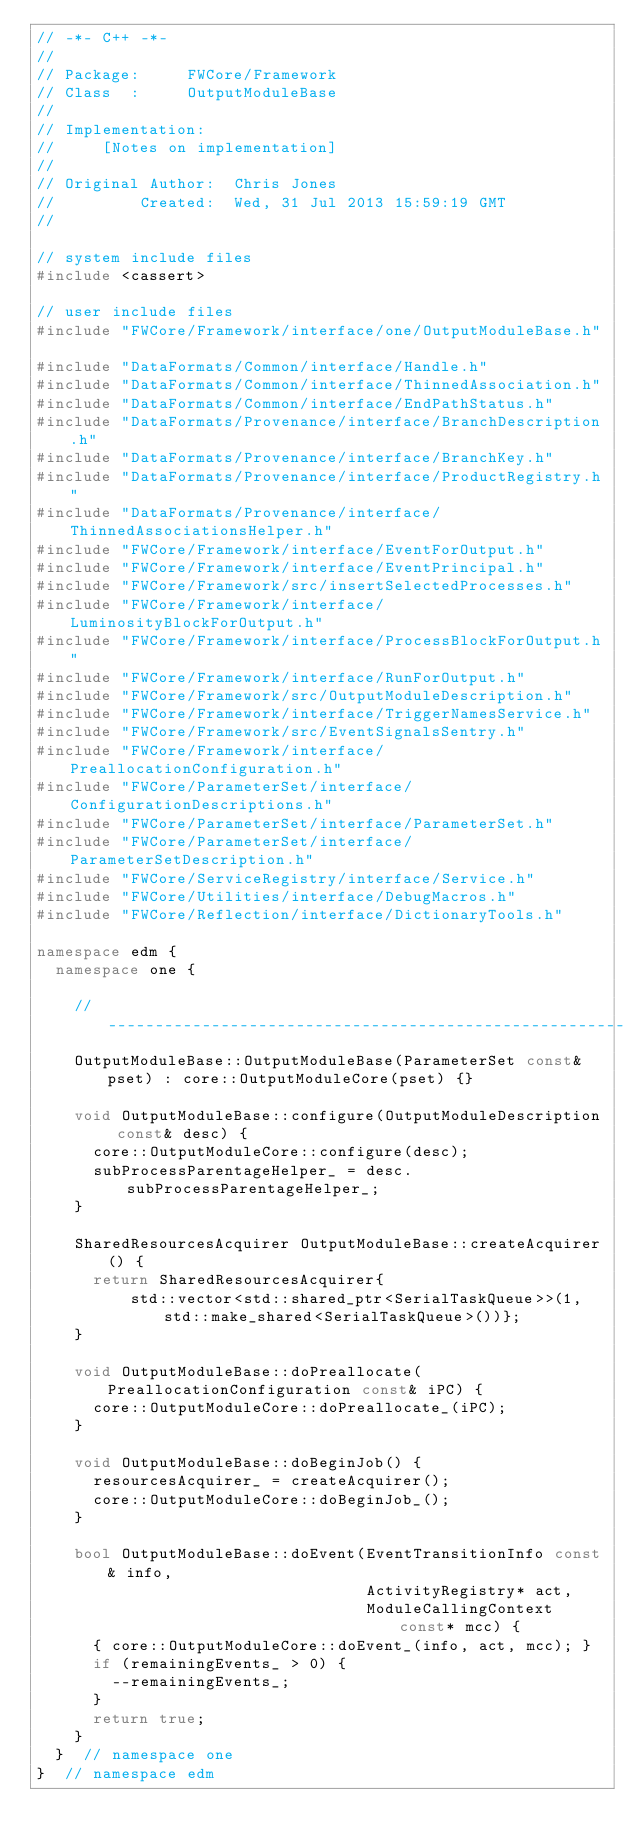Convert code to text. <code><loc_0><loc_0><loc_500><loc_500><_C++_>// -*- C++ -*-
//
// Package:     FWCore/Framework
// Class  :     OutputModuleBase
//
// Implementation:
//     [Notes on implementation]
//
// Original Author:  Chris Jones
//         Created:  Wed, 31 Jul 2013 15:59:19 GMT
//

// system include files
#include <cassert>

// user include files
#include "FWCore/Framework/interface/one/OutputModuleBase.h"

#include "DataFormats/Common/interface/Handle.h"
#include "DataFormats/Common/interface/ThinnedAssociation.h"
#include "DataFormats/Common/interface/EndPathStatus.h"
#include "DataFormats/Provenance/interface/BranchDescription.h"
#include "DataFormats/Provenance/interface/BranchKey.h"
#include "DataFormats/Provenance/interface/ProductRegistry.h"
#include "DataFormats/Provenance/interface/ThinnedAssociationsHelper.h"
#include "FWCore/Framework/interface/EventForOutput.h"
#include "FWCore/Framework/interface/EventPrincipal.h"
#include "FWCore/Framework/src/insertSelectedProcesses.h"
#include "FWCore/Framework/interface/LuminosityBlockForOutput.h"
#include "FWCore/Framework/interface/ProcessBlockForOutput.h"
#include "FWCore/Framework/interface/RunForOutput.h"
#include "FWCore/Framework/src/OutputModuleDescription.h"
#include "FWCore/Framework/interface/TriggerNamesService.h"
#include "FWCore/Framework/src/EventSignalsSentry.h"
#include "FWCore/Framework/interface/PreallocationConfiguration.h"
#include "FWCore/ParameterSet/interface/ConfigurationDescriptions.h"
#include "FWCore/ParameterSet/interface/ParameterSet.h"
#include "FWCore/ParameterSet/interface/ParameterSetDescription.h"
#include "FWCore/ServiceRegistry/interface/Service.h"
#include "FWCore/Utilities/interface/DebugMacros.h"
#include "FWCore/Reflection/interface/DictionaryTools.h"

namespace edm {
  namespace one {

    // -------------------------------------------------------
    OutputModuleBase::OutputModuleBase(ParameterSet const& pset) : core::OutputModuleCore(pset) {}

    void OutputModuleBase::configure(OutputModuleDescription const& desc) {
      core::OutputModuleCore::configure(desc);
      subProcessParentageHelper_ = desc.subProcessParentageHelper_;
    }

    SharedResourcesAcquirer OutputModuleBase::createAcquirer() {
      return SharedResourcesAcquirer{
          std::vector<std::shared_ptr<SerialTaskQueue>>(1, std::make_shared<SerialTaskQueue>())};
    }

    void OutputModuleBase::doPreallocate(PreallocationConfiguration const& iPC) {
      core::OutputModuleCore::doPreallocate_(iPC);
    }

    void OutputModuleBase::doBeginJob() {
      resourcesAcquirer_ = createAcquirer();
      core::OutputModuleCore::doBeginJob_();
    }

    bool OutputModuleBase::doEvent(EventTransitionInfo const& info,
                                   ActivityRegistry* act,
                                   ModuleCallingContext const* mcc) {
      { core::OutputModuleCore::doEvent_(info, act, mcc); }
      if (remainingEvents_ > 0) {
        --remainingEvents_;
      }
      return true;
    }
  }  // namespace one
}  // namespace edm
</code> 